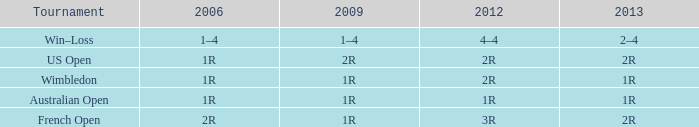What is the Tournament when the 2013 is 1r? Australian Open, Wimbledon. 